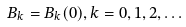<formula> <loc_0><loc_0><loc_500><loc_500>B _ { k } = B _ { k } ( 0 ) , k = 0 , 1 , 2 , \dots</formula> 